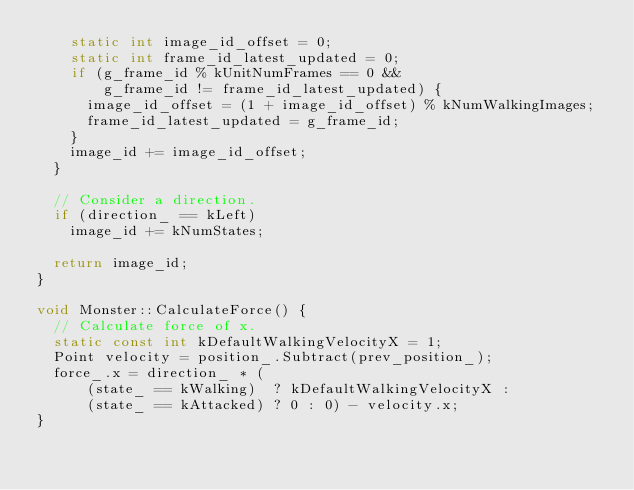<code> <loc_0><loc_0><loc_500><loc_500><_C++_>    static int image_id_offset = 0;
    static int frame_id_latest_updated = 0;
    if (g_frame_id % kUnitNumFrames == 0 &&
        g_frame_id != frame_id_latest_updated) {
      image_id_offset = (1 + image_id_offset) % kNumWalkingImages;
      frame_id_latest_updated = g_frame_id;
    }
    image_id += image_id_offset;
  }

  // Consider a direction.
  if (direction_ == kLeft)
    image_id += kNumStates;

  return image_id;
}

void Monster::CalculateForce() {
  // Calculate force of x.
  static const int kDefaultWalkingVelocityX = 1;
  Point velocity = position_.Subtract(prev_position_);
  force_.x = direction_ * (
      (state_ == kWalking)  ? kDefaultWalkingVelocityX :
      (state_ == kAttacked) ? 0 : 0) - velocity.x;
}</code> 